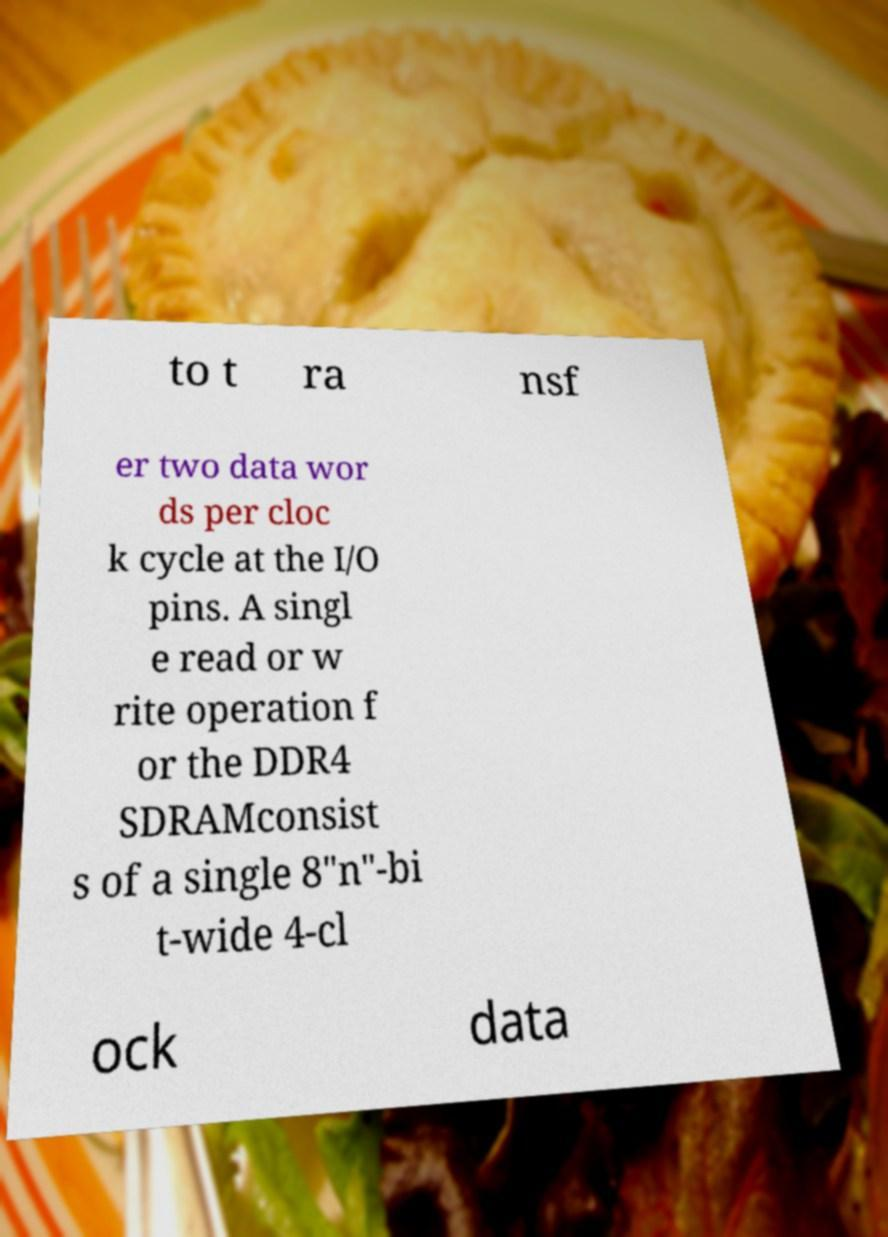Please identify and transcribe the text found in this image. to t ra nsf er two data wor ds per cloc k cycle at the I/O pins. A singl e read or w rite operation f or the DDR4 SDRAMconsist s of a single 8"n"-bi t-wide 4-cl ock data 